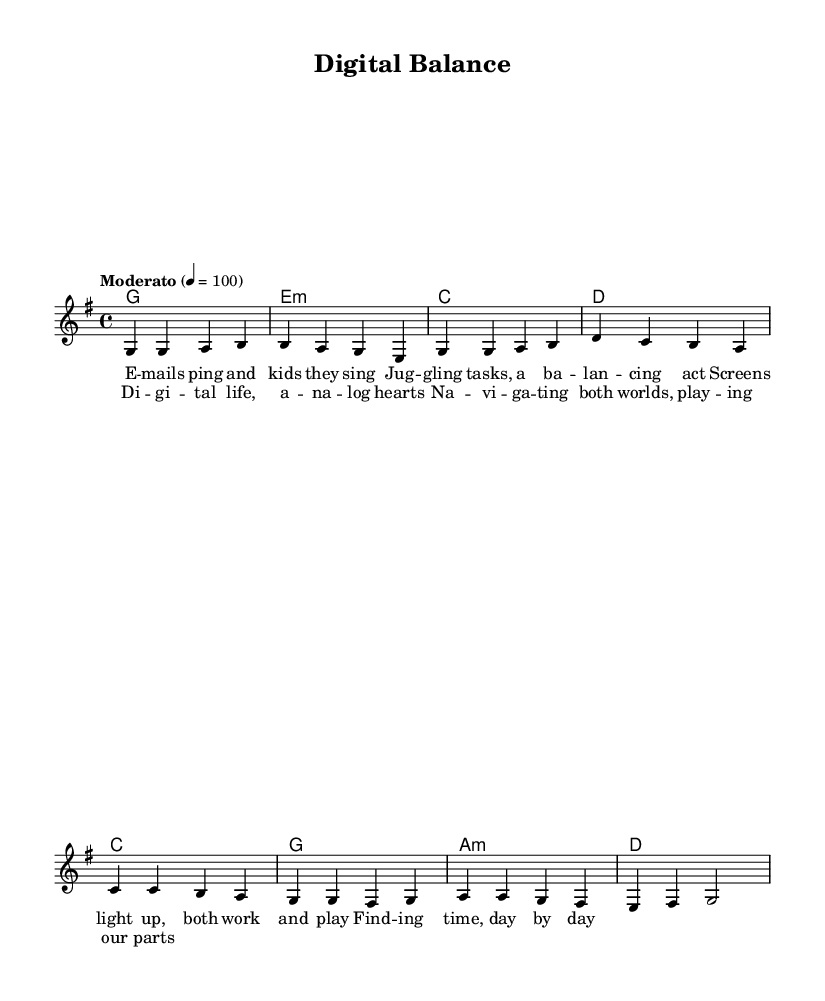What is the key signature of this music? The key signature is G major, indicated by one sharp (F#).
Answer: G major What is the time signature of this music? The time signature is 4/4, which means there are four beats in a measure and a quarter note gets one beat.
Answer: 4/4 What is the tempo marking of this piece? The tempo marking is Moderato, which means a moderate speed, set at 100 beats per minute.
Answer: Moderato How many measures are in the verse section? Counting the measures in the verse, there are four distinct measures, as seen in the melody section.
Answer: 4 In which section do the lyrics mention "balancing"? The word "balancing" appears in the verse section, during the line about juggling tasks.
Answer: Verse What is the function of the chords in the chorus? The chords in the chorus serve to support the melody and enhance the emotional expression of navigating between digital and analog lives.
Answer: Support What musical style does this piece exemplify? This piece exemplifies the folk genre, characterized by its lyrical storytelling and relatable themes about everyday life.
Answer: Folk 